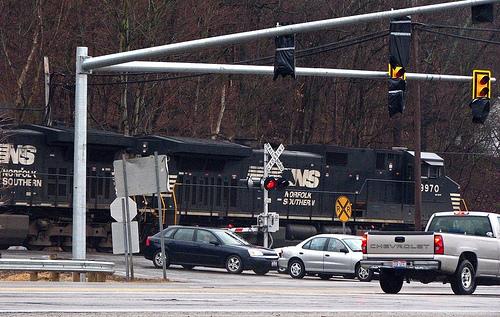What is the brand of truck?
Quick response, please. Chevrolet. How many cars are there?
Give a very brief answer. 3. Can someone drive past right now?
Write a very short answer. No. 